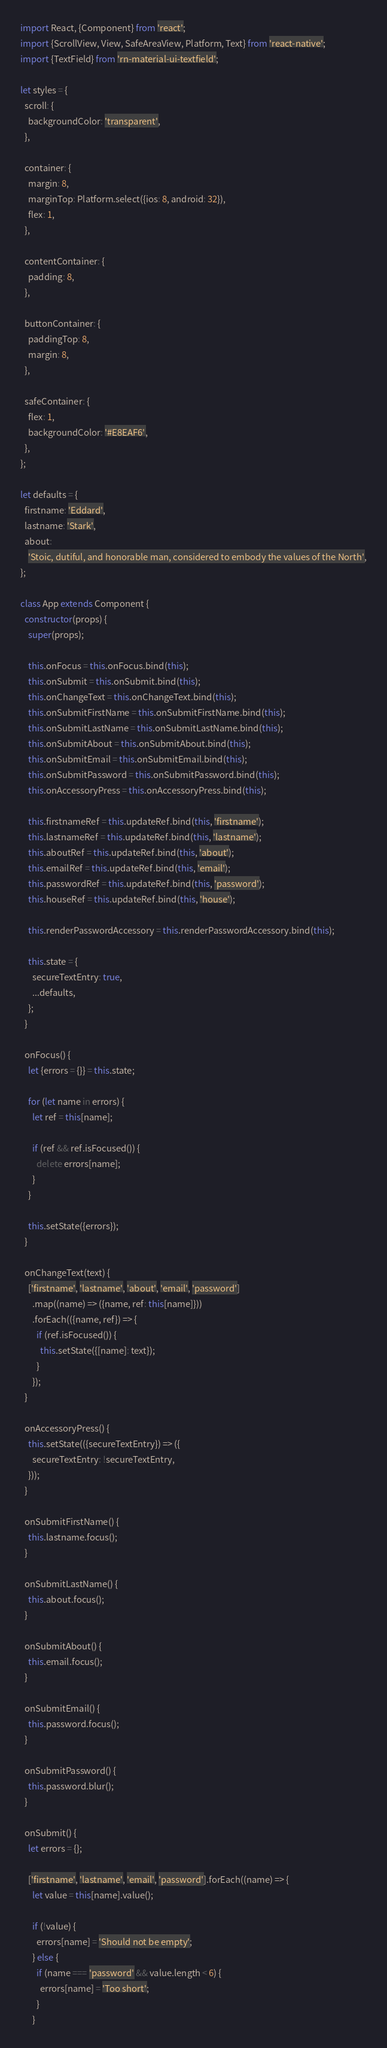<code> <loc_0><loc_0><loc_500><loc_500><_JavaScript_>import React, {Component} from 'react';
import {ScrollView, View, SafeAreaView, Platform, Text} from 'react-native';
import {TextField} from 'rn-material-ui-textfield';

let styles = {
  scroll: {
    backgroundColor: 'transparent',
  },

  container: {
    margin: 8,
    marginTop: Platform.select({ios: 8, android: 32}),
    flex: 1,
  },

  contentContainer: {
    padding: 8,
  },

  buttonContainer: {
    paddingTop: 8,
    margin: 8,
  },

  safeContainer: {
    flex: 1,
    backgroundColor: '#E8EAF6',
  },
};

let defaults = {
  firstname: 'Eddard',
  lastname: 'Stark',
  about:
    'Stoic, dutiful, and honorable man, considered to embody the values of the North',
};

class App extends Component {
  constructor(props) {
    super(props);

    this.onFocus = this.onFocus.bind(this);
    this.onSubmit = this.onSubmit.bind(this);
    this.onChangeText = this.onChangeText.bind(this);
    this.onSubmitFirstName = this.onSubmitFirstName.bind(this);
    this.onSubmitLastName = this.onSubmitLastName.bind(this);
    this.onSubmitAbout = this.onSubmitAbout.bind(this);
    this.onSubmitEmail = this.onSubmitEmail.bind(this);
    this.onSubmitPassword = this.onSubmitPassword.bind(this);
    this.onAccessoryPress = this.onAccessoryPress.bind(this);

    this.firstnameRef = this.updateRef.bind(this, 'firstname');
    this.lastnameRef = this.updateRef.bind(this, 'lastname');
    this.aboutRef = this.updateRef.bind(this, 'about');
    this.emailRef = this.updateRef.bind(this, 'email');
    this.passwordRef = this.updateRef.bind(this, 'password');
    this.houseRef = this.updateRef.bind(this, 'house');

    this.renderPasswordAccessory = this.renderPasswordAccessory.bind(this);

    this.state = {
      secureTextEntry: true,
      ...defaults,
    };
  }

  onFocus() {
    let {errors = {}} = this.state;

    for (let name in errors) {
      let ref = this[name];

      if (ref && ref.isFocused()) {
        delete errors[name];
      }
    }

    this.setState({errors});
  }

  onChangeText(text) {
    ['firstname', 'lastname', 'about', 'email', 'password']
      .map((name) => ({name, ref: this[name]}))
      .forEach(({name, ref}) => {
        if (ref.isFocused()) {
          this.setState({[name]: text});
        }
      });
  }

  onAccessoryPress() {
    this.setState(({secureTextEntry}) => ({
      secureTextEntry: !secureTextEntry,
    }));
  }

  onSubmitFirstName() {
    this.lastname.focus();
  }

  onSubmitLastName() {
    this.about.focus();
  }

  onSubmitAbout() {
    this.email.focus();
  }

  onSubmitEmail() {
    this.password.focus();
  }

  onSubmitPassword() {
    this.password.blur();
  }

  onSubmit() {
    let errors = {};

    ['firstname', 'lastname', 'email', 'password'].forEach((name) => {
      let value = this[name].value();

      if (!value) {
        errors[name] = 'Should not be empty';
      } else {
        if (name === 'password' && value.length < 6) {
          errors[name] = 'Too short';
        }
      }</code> 